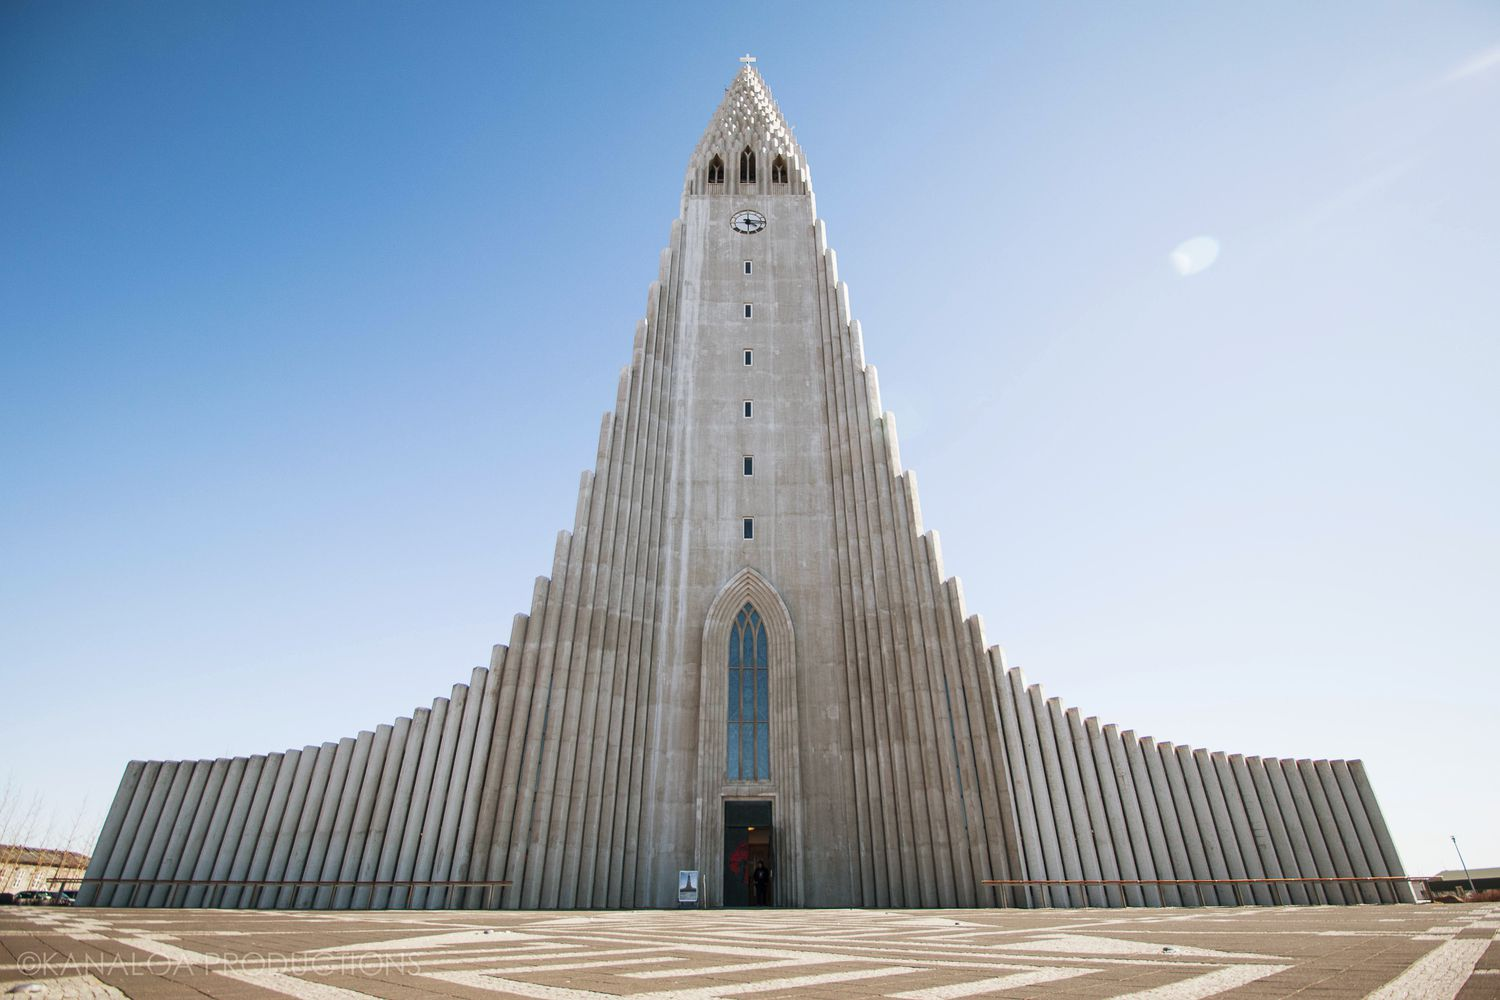What are some casual details one might notice if they were visiting this location? Visitors might notice the intricate patterns on the church's facade, which mimic the natural basalt columns found throughout Iceland. The sun casts interesting shadows on the stone, changing the appearance of the church throughout the day. Nearby, there's often a small gathering of people, some taking photos, others simply sitting and enjoying the view. Local cafes around the area offer a cozy spot to relax after visiting the church, with the aroma of freshly brewed coffee wafting through the air. The quiet hum of city life in the surroundings contrasts nicely with the serene atmosphere of the church itself. 